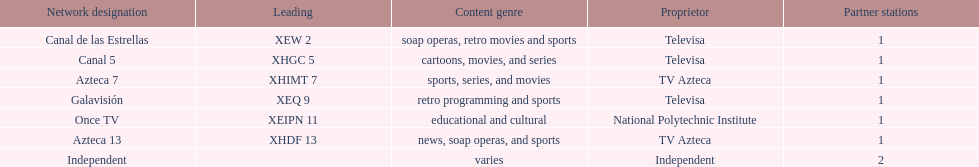Azteca 7 and azteca 13 are both owned by whom? TV Azteca. 